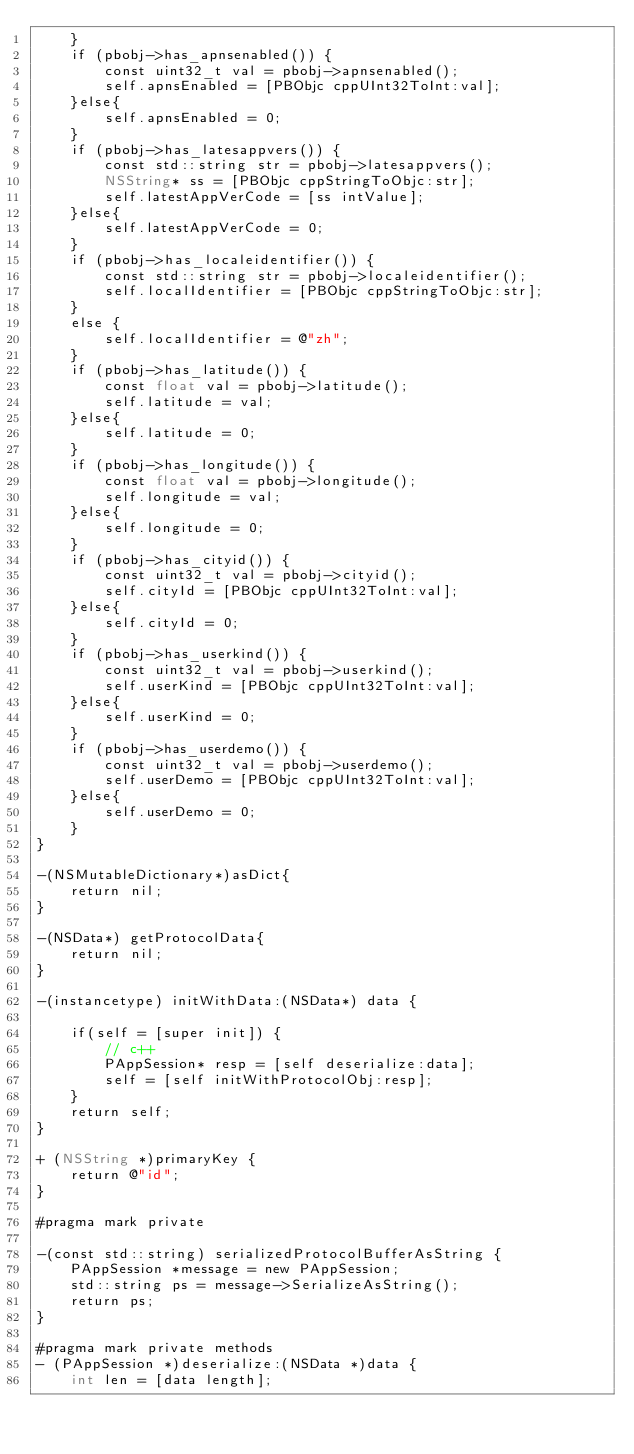Convert code to text. <code><loc_0><loc_0><loc_500><loc_500><_ObjectiveC_>    }
    if (pbobj->has_apnsenabled()) {
        const uint32_t val = pbobj->apnsenabled();
        self.apnsEnabled = [PBObjc cppUInt32ToInt:val];
    }else{
        self.apnsEnabled = 0;
    }
    if (pbobj->has_latesappvers()) {
        const std::string str = pbobj->latesappvers();
        NSString* ss = [PBObjc cppStringToObjc:str];
        self.latestAppVerCode = [ss intValue];
    }else{
        self.latestAppVerCode = 0;
    }
    if (pbobj->has_localeidentifier()) {
        const std::string str = pbobj->localeidentifier();
        self.localIdentifier = [PBObjc cppStringToObjc:str];
    }
    else {
        self.localIdentifier = @"zh";
    }
    if (pbobj->has_latitude()) {
        const float val = pbobj->latitude();
        self.latitude = val;
    }else{
        self.latitude = 0;
    }
    if (pbobj->has_longitude()) {
        const float val = pbobj->longitude();
        self.longitude = val;
    }else{
        self.longitude = 0;
    }
    if (pbobj->has_cityid()) {
        const uint32_t val = pbobj->cityid();
        self.cityId = [PBObjc cppUInt32ToInt:val];
    }else{
        self.cityId = 0;
    }
    if (pbobj->has_userkind()) {
        const uint32_t val = pbobj->userkind();
        self.userKind = [PBObjc cppUInt32ToInt:val];
    }else{
        self.userKind = 0;
    }
    if (pbobj->has_userdemo()) {
        const uint32_t val = pbobj->userdemo();
        self.userDemo = [PBObjc cppUInt32ToInt:val];
    }else{
        self.userDemo = 0;
    }
}

-(NSMutableDictionary*)asDict{
    return nil;
}

-(NSData*) getProtocolData{
    return nil;
}

-(instancetype) initWithData:(NSData*) data {
    
    if(self = [super init]) {
        // c++
        PAppSession* resp = [self deserialize:data];
        self = [self initWithProtocolObj:resp];
    }
    return self;
}

+ (NSString *)primaryKey {
    return @"id";
}

#pragma mark private

-(const std::string) serializedProtocolBufferAsString {
    PAppSession *message = new PAppSession;
    std::string ps = message->SerializeAsString();
    return ps;
}

#pragma mark private methods
- (PAppSession *)deserialize:(NSData *)data {
    int len = [data length];</code> 